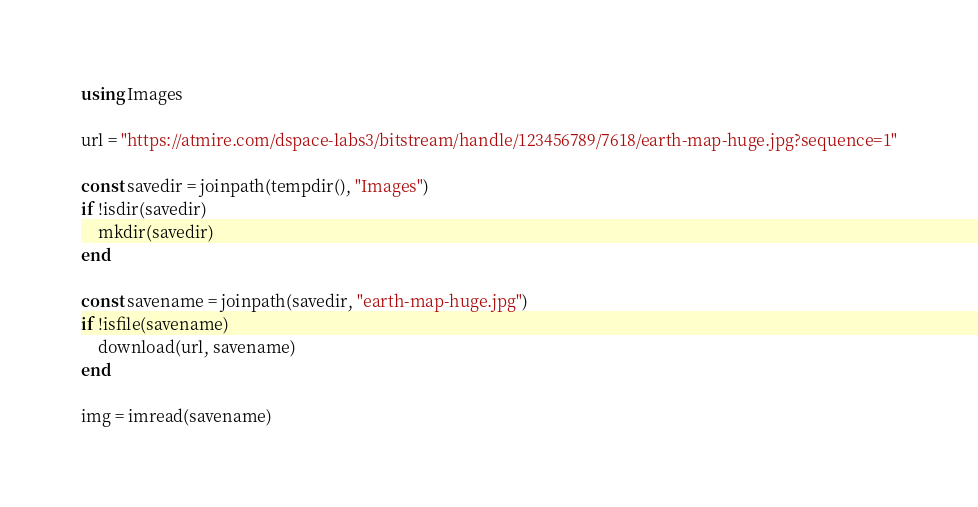Convert code to text. <code><loc_0><loc_0><loc_500><loc_500><_Julia_>using Images

url = "https://atmire.com/dspace-labs3/bitstream/handle/123456789/7618/earth-map-huge.jpg?sequence=1"

const savedir = joinpath(tempdir(), "Images")
if !isdir(savedir)
    mkdir(savedir)
end

const savename = joinpath(savedir, "earth-map-huge.jpg")
if !isfile(savename)
    download(url, savename)
end

img = imread(savename)
</code> 